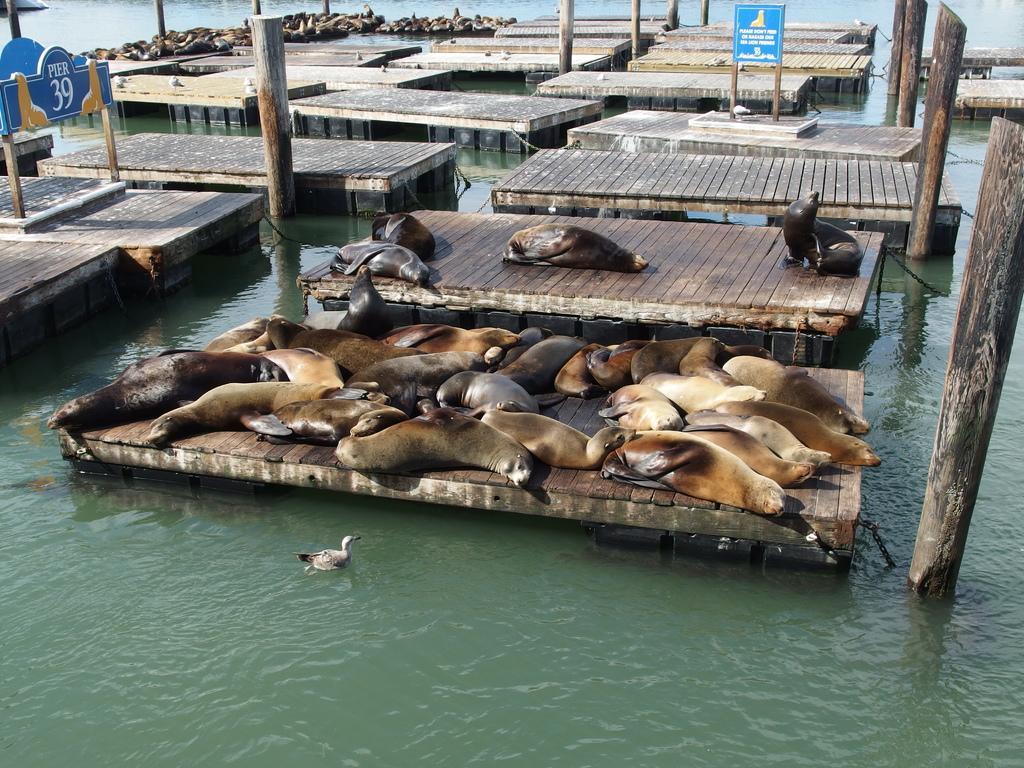Please provide a concise description of this image. In this picture I can see there are few seals lying on the wooden surface and there is a duck swimming in the water and there are few more wooden tables in the backdrop. Onto left I can see there are few seals on the wooden tables. There is water around them. There are wooden pillars. 